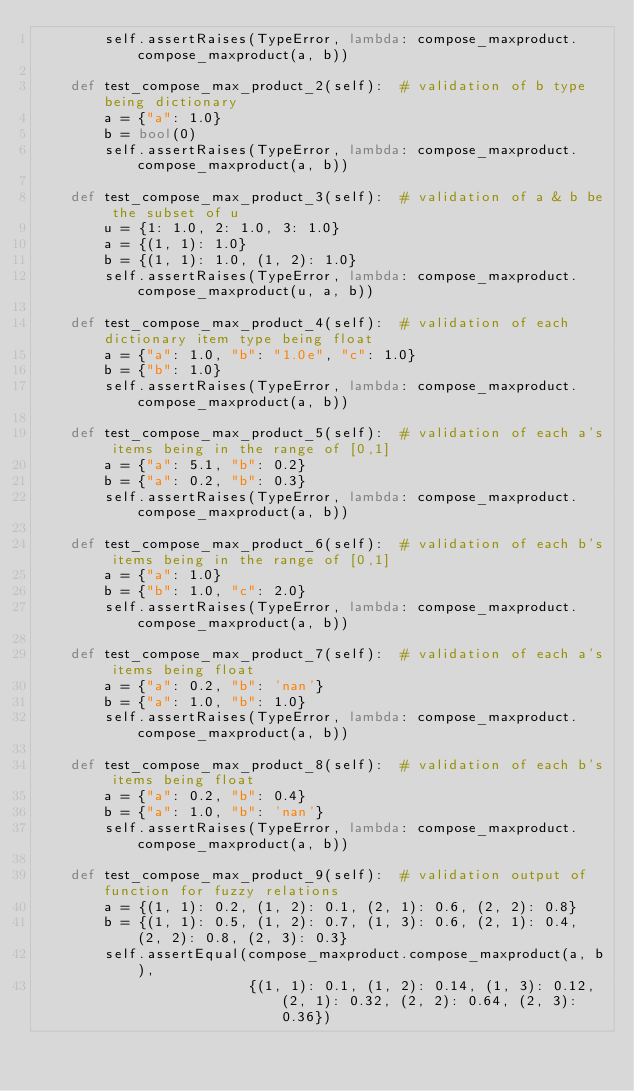<code> <loc_0><loc_0><loc_500><loc_500><_Python_>        self.assertRaises(TypeError, lambda: compose_maxproduct.compose_maxproduct(a, b))

    def test_compose_max_product_2(self):  # validation of b type being dictionary
        a = {"a": 1.0}
        b = bool(0)
        self.assertRaises(TypeError, lambda: compose_maxproduct.compose_maxproduct(a, b))

    def test_compose_max_product_3(self):  # validation of a & b be the subset of u
        u = {1: 1.0, 2: 1.0, 3: 1.0}
        a = {(1, 1): 1.0}
        b = {(1, 1): 1.0, (1, 2): 1.0}
        self.assertRaises(TypeError, lambda: compose_maxproduct.compose_maxproduct(u, a, b))

    def test_compose_max_product_4(self):  # validation of each dictionary item type being float
        a = {"a": 1.0, "b": "1.0e", "c": 1.0}
        b = {"b": 1.0}
        self.assertRaises(TypeError, lambda: compose_maxproduct.compose_maxproduct(a, b))

    def test_compose_max_product_5(self):  # validation of each a's items being in the range of [0,1]
        a = {"a": 5.1, "b": 0.2}
        b = {"a": 0.2, "b": 0.3}
        self.assertRaises(TypeError, lambda: compose_maxproduct.compose_maxproduct(a, b))

    def test_compose_max_product_6(self):  # validation of each b's items being in the range of [0,1]
        a = {"a": 1.0}
        b = {"b": 1.0, "c": 2.0}
        self.assertRaises(TypeError, lambda: compose_maxproduct.compose_maxproduct(a, b))

    def test_compose_max_product_7(self):  # validation of each a's items being float
        a = {"a": 0.2, "b": 'nan'}
        b = {"a": 1.0, "b": 1.0}
        self.assertRaises(TypeError, lambda: compose_maxproduct.compose_maxproduct(a, b))

    def test_compose_max_product_8(self):  # validation of each b's items being float
        a = {"a": 0.2, "b": 0.4}
        b = {"a": 1.0, "b": 'nan'}
        self.assertRaises(TypeError, lambda: compose_maxproduct.compose_maxproduct(a, b))

    def test_compose_max_product_9(self):  # validation output of function for fuzzy relations
        a = {(1, 1): 0.2, (1, 2): 0.1, (2, 1): 0.6, (2, 2): 0.8}
        b = {(1, 1): 0.5, (1, 2): 0.7, (1, 3): 0.6, (2, 1): 0.4, (2, 2): 0.8, (2, 3): 0.3}
        self.assertEqual(compose_maxproduct.compose_maxproduct(a, b),
                         {(1, 1): 0.1, (1, 2): 0.14, (1, 3): 0.12, (2, 1): 0.32, (2, 2): 0.64, (2, 3): 0.36})
</code> 